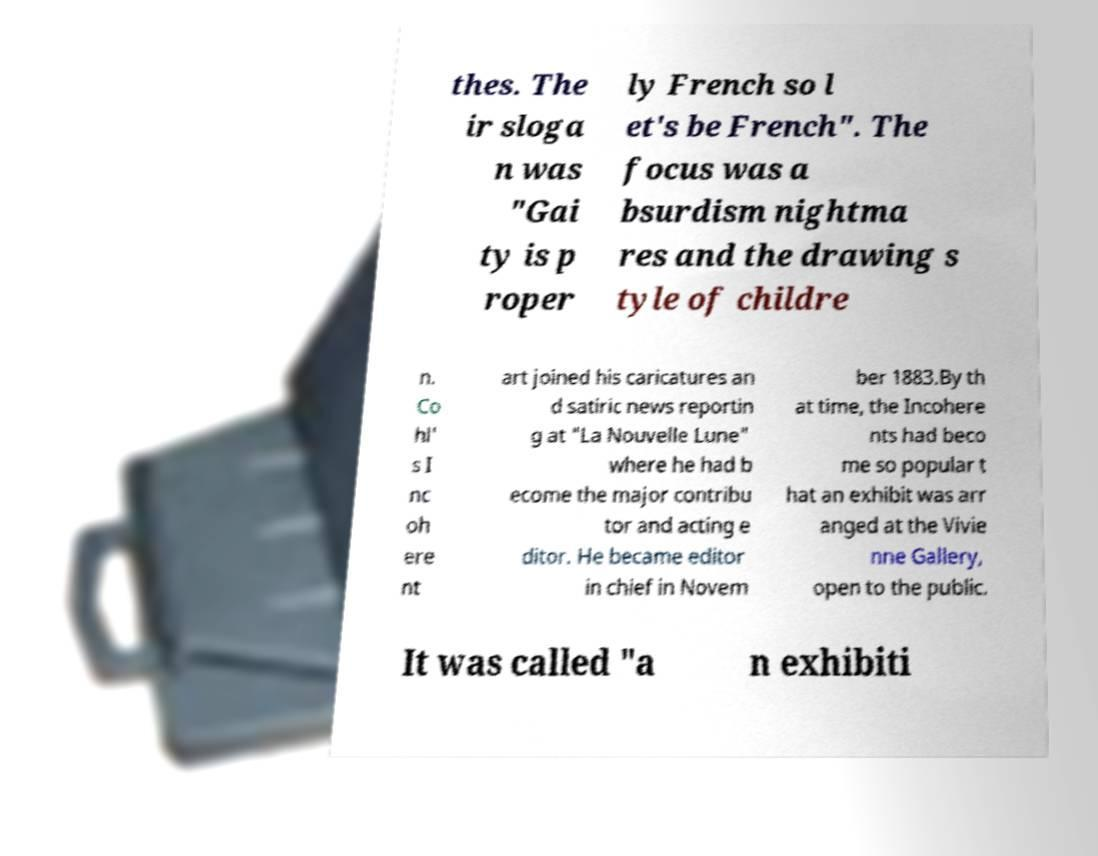Could you extract and type out the text from this image? thes. The ir sloga n was "Gai ty is p roper ly French so l et's be French". The focus was a bsurdism nightma res and the drawing s tyle of childre n. Co hl' s I nc oh ere nt art joined his caricatures an d satiric news reportin g at "La Nouvelle Lune" where he had b ecome the major contribu tor and acting e ditor. He became editor in chief in Novem ber 1883.By th at time, the Incohere nts had beco me so popular t hat an exhibit was arr anged at the Vivie nne Gallery, open to the public. It was called "a n exhibiti 